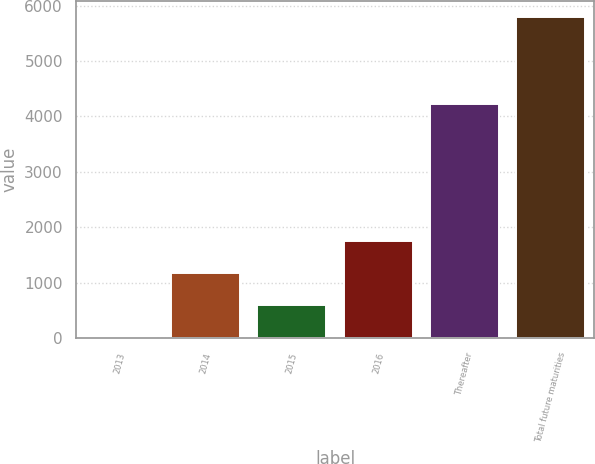<chart> <loc_0><loc_0><loc_500><loc_500><bar_chart><fcel>2013<fcel>2014<fcel>2015<fcel>2016<fcel>Thereafter<fcel>Total future maturities<nl><fcel>17<fcel>1173.8<fcel>595.4<fcel>1752.2<fcel>4221<fcel>5801<nl></chart> 